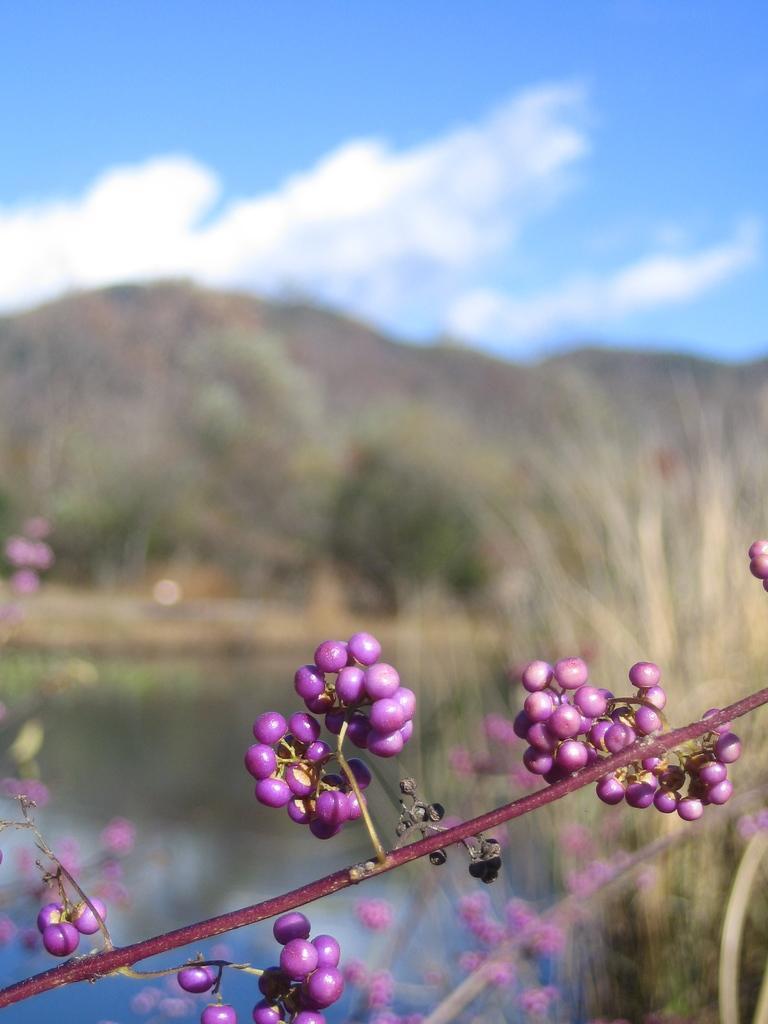Could you give a brief overview of what you see in this image? In the picture we can see a part of the stem with fruits and behind it, we can see the water surface, grass, hills and the sky with clouds. 